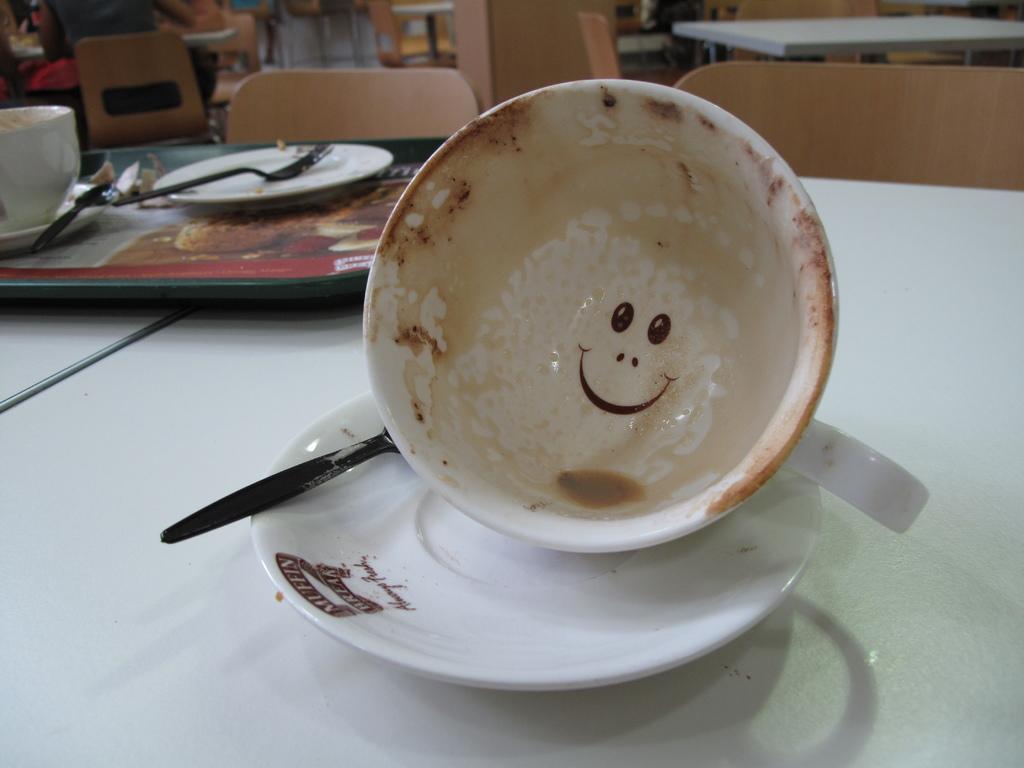Could you give a brief overview of what you see in this image? On a table there are cups,saucers and spoons. In the background we can see chairs and tables and few people. 